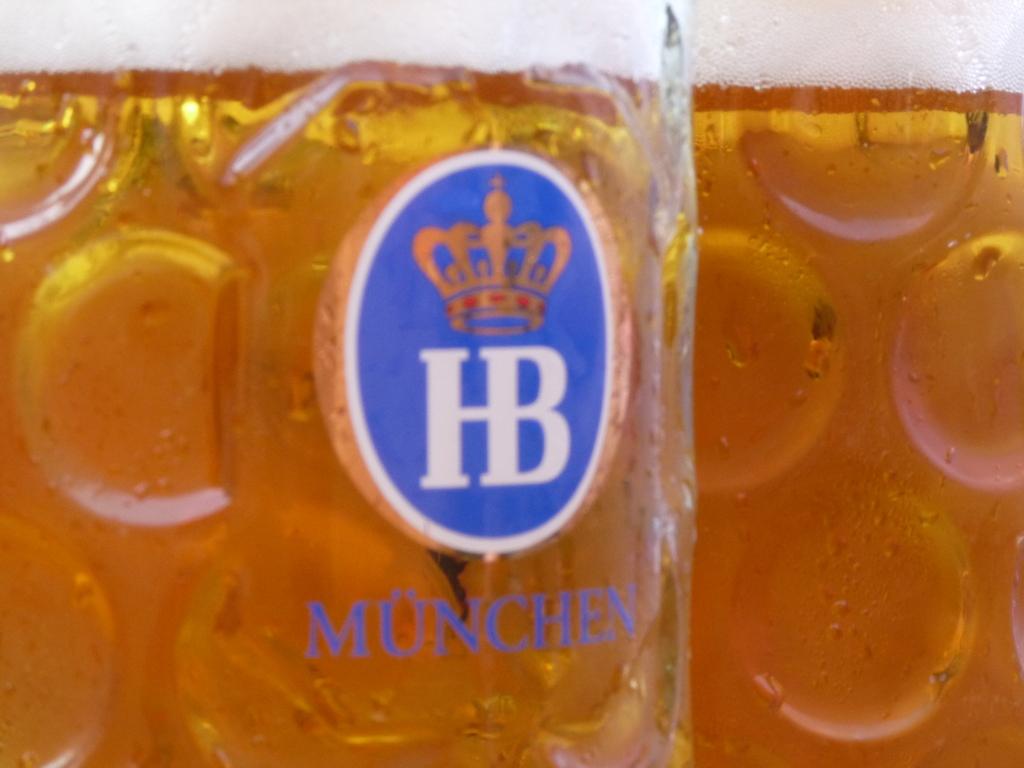What is the brand?
Offer a terse response. Hb. 